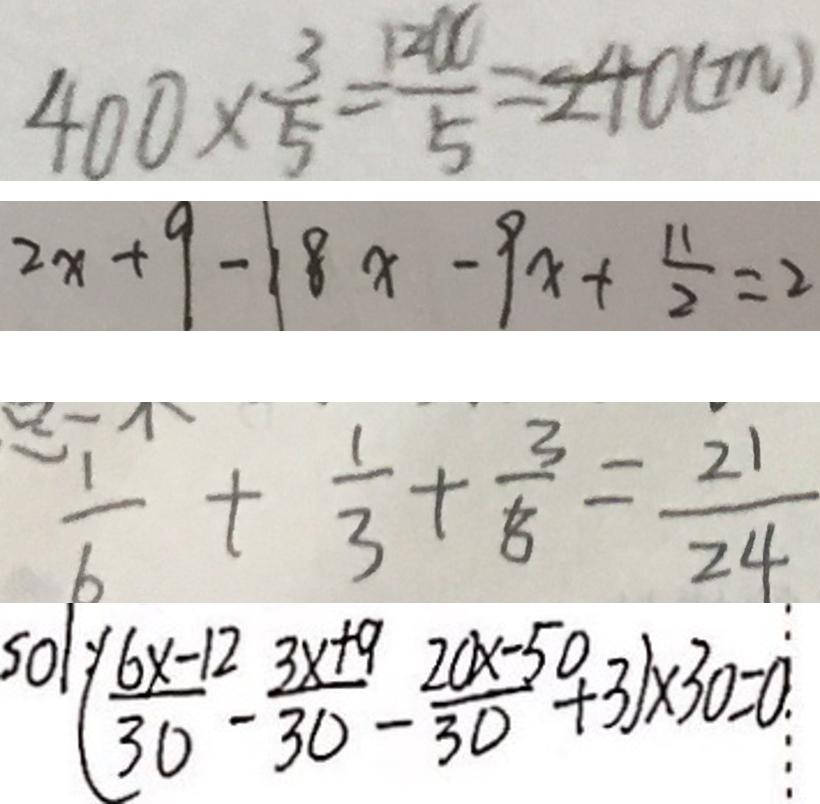<formula> <loc_0><loc_0><loc_500><loc_500>4 0 0 \times \frac { 3 } { 5 } = \frac { 1 2 U } { 5 } = 2 4 0 ( m ) 
 2 x + 9 - 1 8 x - 9 x + \frac { 1 1 } { 2 } = 2 
 \frac { 1 } { 6 } + \frac { 1 } { 3 } + \frac { 3 } { 8 } = \frac { 2 1 } { 2 4 } 
 5 0 1 ( \frac { 6 x - 1 2 } { 3 0 } - \frac { 3 x + 9 } { 3 0 } - \frac { 2 0 0 x - 5 0 } { 3 0 } + 3 ) \times 3 0 = 0</formula> 